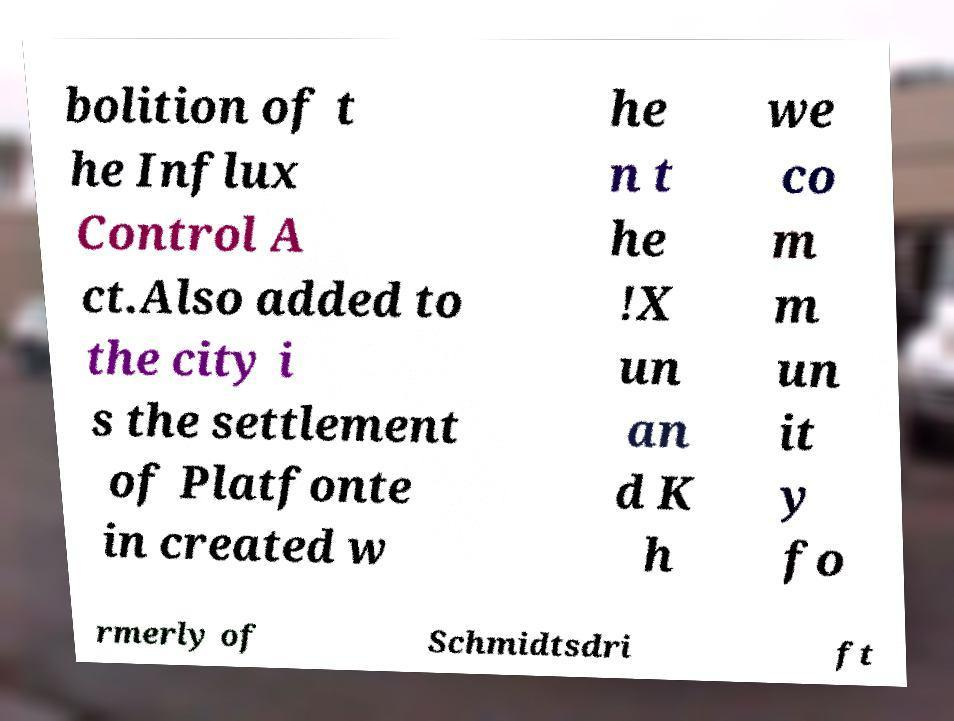Please identify and transcribe the text found in this image. bolition of t he Influx Control A ct.Also added to the city i s the settlement of Platfonte in created w he n t he !X un an d K h we co m m un it y fo rmerly of Schmidtsdri ft 